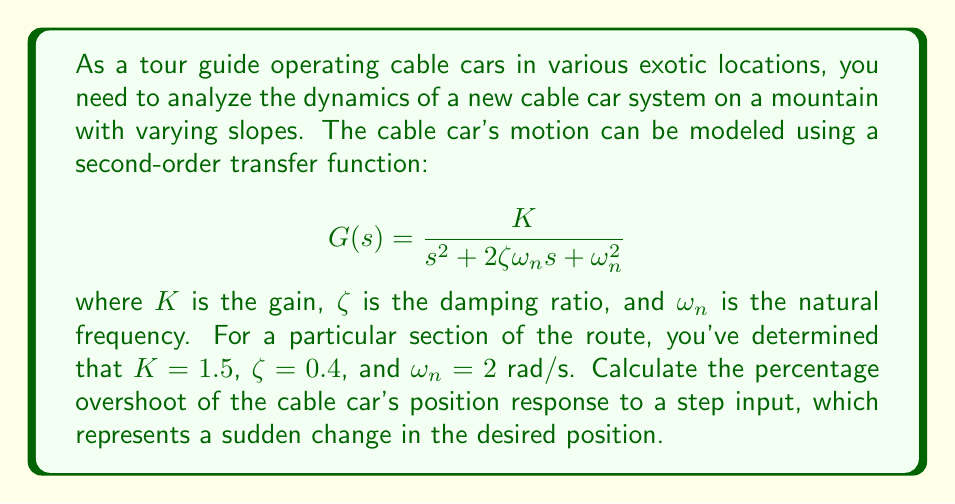Could you help me with this problem? To solve this problem, we'll follow these steps:

1) The percentage overshoot (PO) for a second-order system is given by the formula:

   $$PO = 100 \cdot e^{-\frac{\zeta\pi}{\sqrt{1-\zeta^2}}}$$

2) We're given that $\zeta = 0.4$. Let's substitute this into the formula:

   $$PO = 100 \cdot e^{-\frac{0.4\pi}{\sqrt{1-0.4^2}}}$$

3) First, let's calculate the denominator inside the exponential:
   
   $$\sqrt{1-0.4^2} = \sqrt{1-0.16} = \sqrt{0.84} \approx 0.9165$$

4) Now, let's calculate the entire exponent:

   $$\frac{0.4\pi}{0.9165} \approx 1.3744$$

5) Next, we calculate the exponential:

   $$e^{-1.3744} \approx 0.2530$$

6) Finally, we multiply by 100 to get the percentage:

   $$100 \cdot 0.2530 \approx 25.30$$

Therefore, the percentage overshoot is approximately 25.30%.

Note: The gain $K$ and natural frequency $\omega_n$ don't affect the percentage overshoot, which depends only on the damping ratio $\zeta$.
Answer: The percentage overshoot of the cable car's position response is approximately 25.30%. 